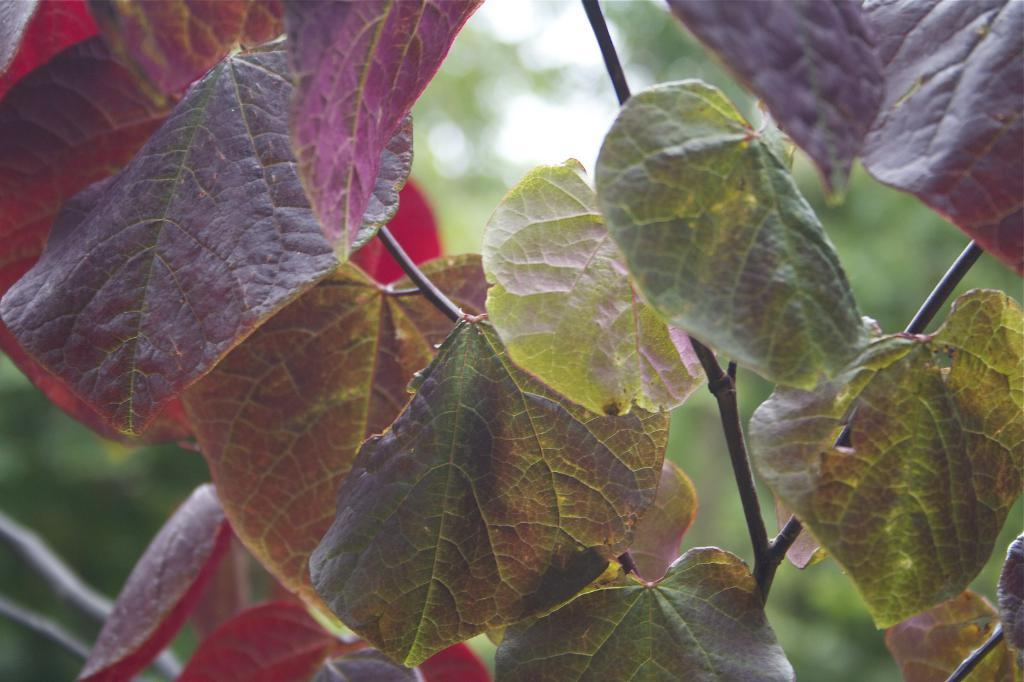What is located in the foreground of the image? There is a plant in the foreground of the image. What colors can be seen on the leaves of the plant? The leaves of the plant have green and maroon colors. How would you describe the background of the image? The background of the image is blurry. What type of cake can be seen in the image? There is no cake present in the image; it features a plant with green and maroon leaves. What material is the copper twig made of in the image? There is no copper twig present in the image. 